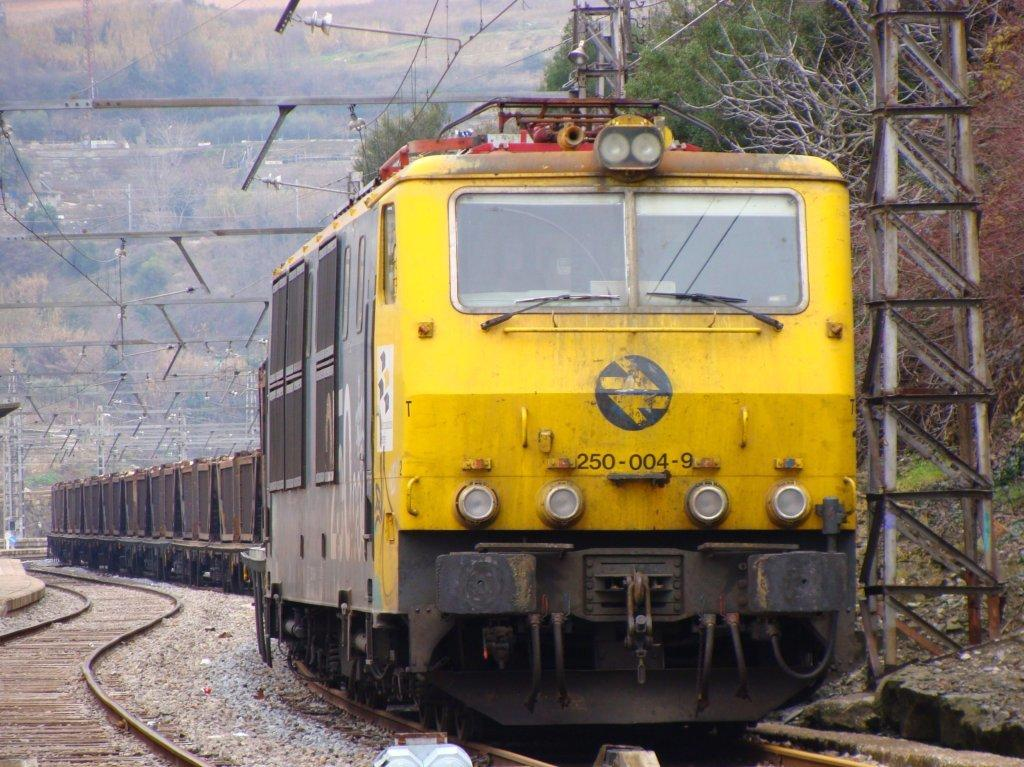<image>
Share a concise interpretation of the image provided. Yellow train going down the tracks with the number 2500049 on the front. 